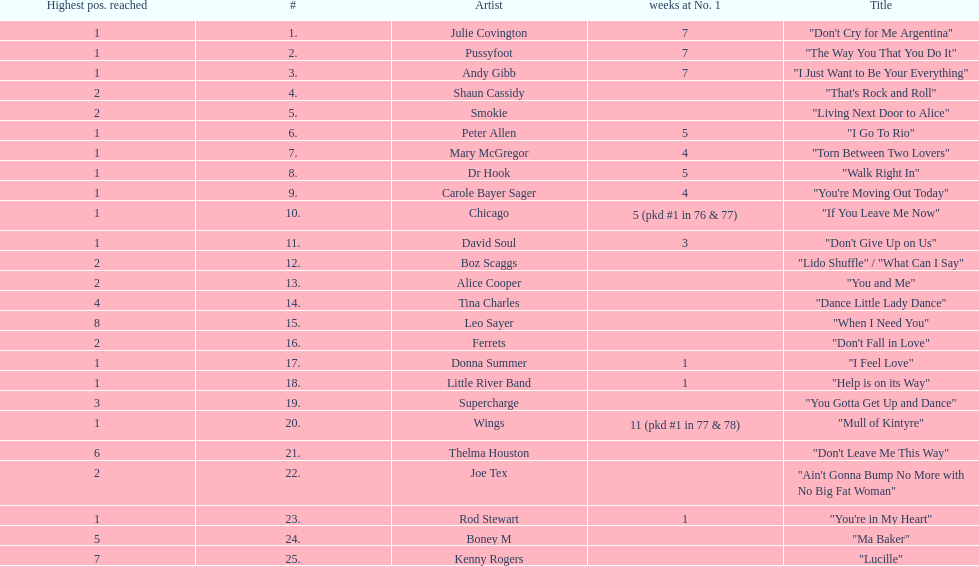Parse the full table. {'header': ['Highest pos. reached', '#', 'Artist', 'weeks at No. 1', 'Title'], 'rows': [['1', '1.', 'Julie Covington', '7', '"Don\'t Cry for Me Argentina"'], ['1', '2.', 'Pussyfoot', '7', '"The Way You That You Do It"'], ['1', '3.', 'Andy Gibb', '7', '"I Just Want to Be Your Everything"'], ['2', '4.', 'Shaun Cassidy', '', '"That\'s Rock and Roll"'], ['2', '5.', 'Smokie', '', '"Living Next Door to Alice"'], ['1', '6.', 'Peter Allen', '5', '"I Go To Rio"'], ['1', '7.', 'Mary McGregor', '4', '"Torn Between Two Lovers"'], ['1', '8.', 'Dr Hook', '5', '"Walk Right In"'], ['1', '9.', 'Carole Bayer Sager', '4', '"You\'re Moving Out Today"'], ['1', '10.', 'Chicago', '5 (pkd #1 in 76 & 77)', '"If You Leave Me Now"'], ['1', '11.', 'David Soul', '3', '"Don\'t Give Up on Us"'], ['2', '12.', 'Boz Scaggs', '', '"Lido Shuffle" / "What Can I Say"'], ['2', '13.', 'Alice Cooper', '', '"You and Me"'], ['4', '14.', 'Tina Charles', '', '"Dance Little Lady Dance"'], ['8', '15.', 'Leo Sayer', '', '"When I Need You"'], ['2', '16.', 'Ferrets', '', '"Don\'t Fall in Love"'], ['1', '17.', 'Donna Summer', '1', '"I Feel Love"'], ['1', '18.', 'Little River Band', '1', '"Help is on its Way"'], ['3', '19.', 'Supercharge', '', '"You Gotta Get Up and Dance"'], ['1', '20.', 'Wings', '11 (pkd #1 in 77 & 78)', '"Mull of Kintyre"'], ['6', '21.', 'Thelma Houston', '', '"Don\'t Leave Me This Way"'], ['2', '22.', 'Joe Tex', '', '"Ain\'t Gonna Bump No More with No Big Fat Woman"'], ['1', '23.', 'Rod Stewart', '1', '"You\'re in My Heart"'], ['5', '24.', 'Boney M', '', '"Ma Baker"'], ['7', '25.', 'Kenny Rogers', '', '"Lucille"']]} What was the number of weeks that julie covington's single " don't cry for me argentinia," was at number 1 in 1977? 7. 